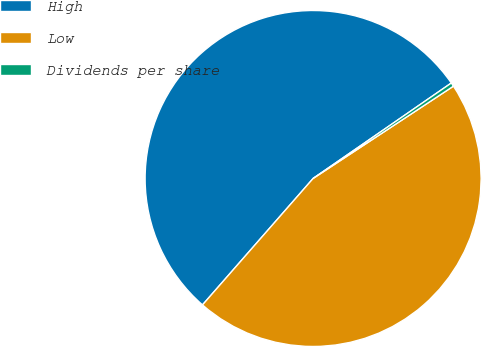Convert chart to OTSL. <chart><loc_0><loc_0><loc_500><loc_500><pie_chart><fcel>High<fcel>Low<fcel>Dividends per share<nl><fcel>53.94%<fcel>45.7%<fcel>0.36%<nl></chart> 